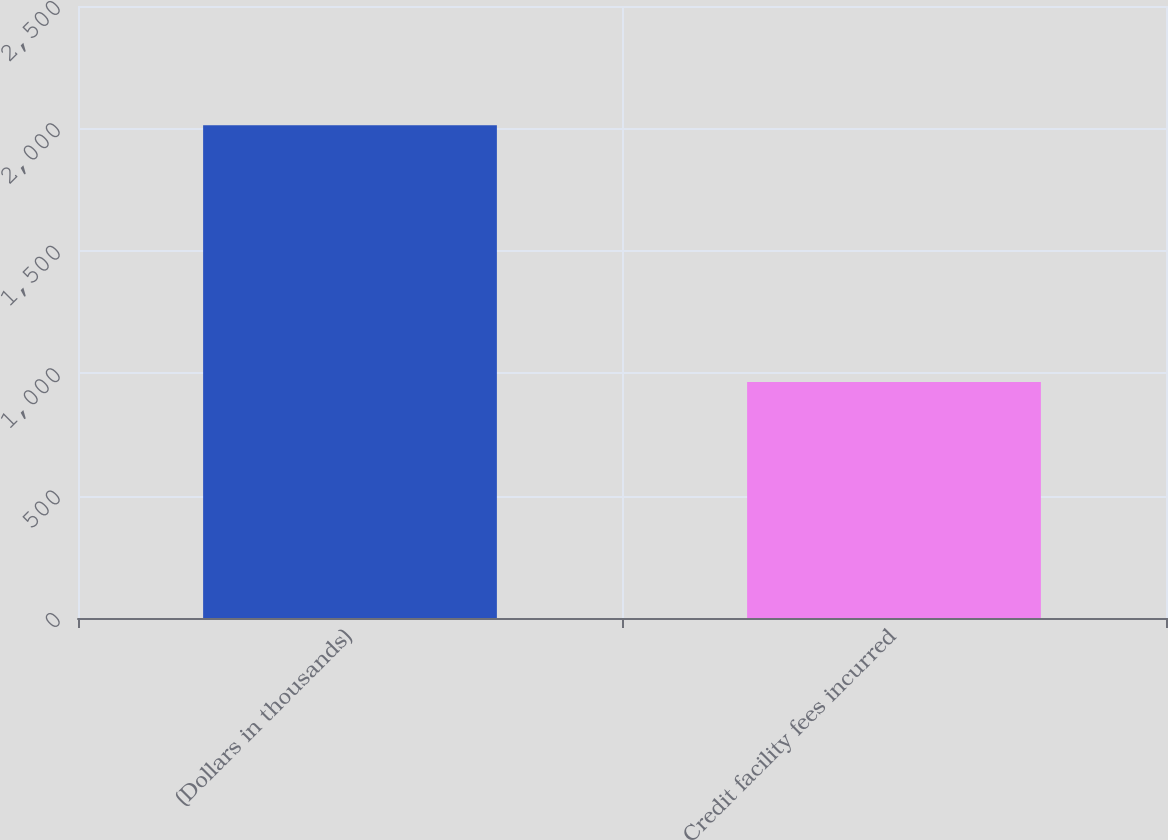Convert chart to OTSL. <chart><loc_0><loc_0><loc_500><loc_500><bar_chart><fcel>(Dollars in thousands)<fcel>Credit facility fees incurred<nl><fcel>2013<fcel>964<nl></chart> 